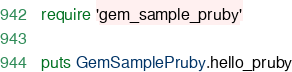Convert code to text. <code><loc_0><loc_0><loc_500><loc_500><_Ruby_>require 'gem_sample_pruby'

puts GemSamplePruby.hello_pruby</code> 